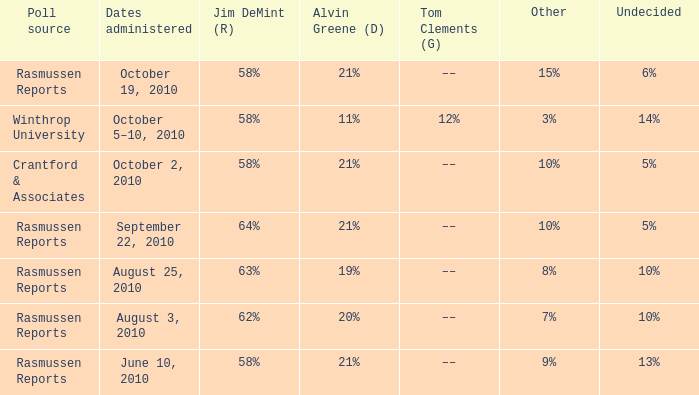What was the vote for Alvin Green when Jim DeMint was 62%? 20%. 